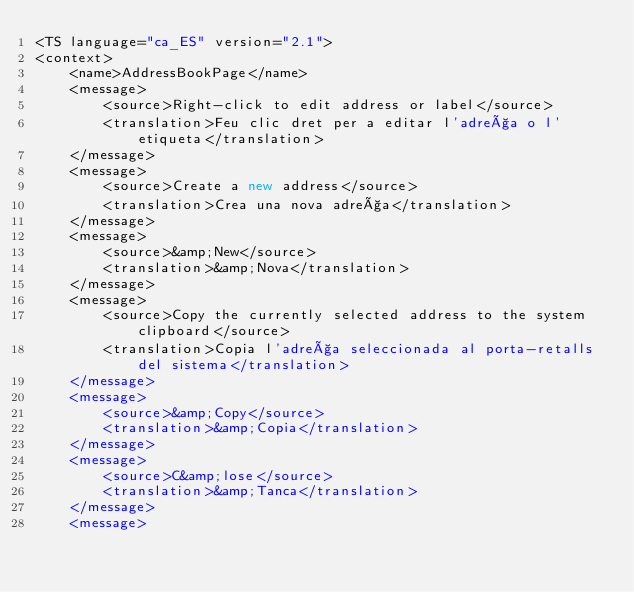<code> <loc_0><loc_0><loc_500><loc_500><_TypeScript_><TS language="ca_ES" version="2.1">
<context>
    <name>AddressBookPage</name>
    <message>
        <source>Right-click to edit address or label</source>
        <translation>Feu clic dret per a editar l'adreça o l'etiqueta</translation>
    </message>
    <message>
        <source>Create a new address</source>
        <translation>Crea una nova adreça</translation>
    </message>
    <message>
        <source>&amp;New</source>
        <translation>&amp;Nova</translation>
    </message>
    <message>
        <source>Copy the currently selected address to the system clipboard</source>
        <translation>Copia l'adreça seleccionada al porta-retalls del sistema</translation>
    </message>
    <message>
        <source>&amp;Copy</source>
        <translation>&amp;Copia</translation>
    </message>
    <message>
        <source>C&amp;lose</source>
        <translation>&amp;Tanca</translation>
    </message>
    <message></code> 